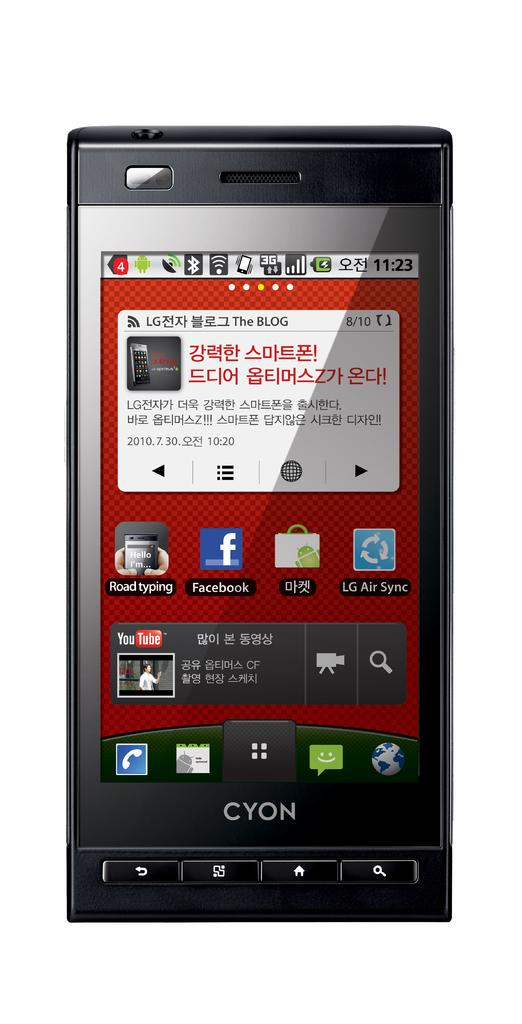Provide a one-sentence caption for the provided image. A black Cyon cell phone with red Chinese writing in red in a white box. 